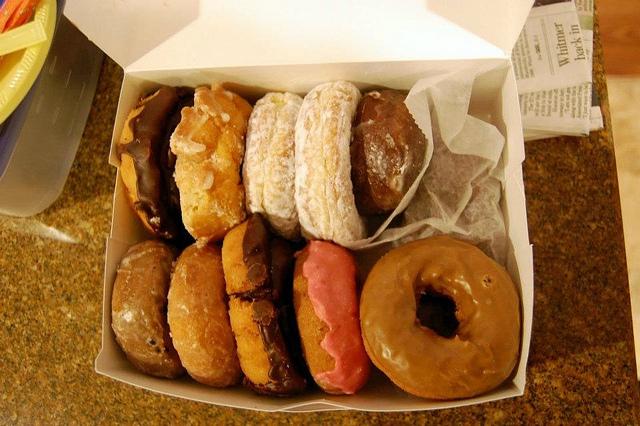Who will eat the donuts?
Answer briefly. People. Are there any cream filled donuts?
Short answer required. Yes. How many doughnuts are there?
Quick response, please. 10. 